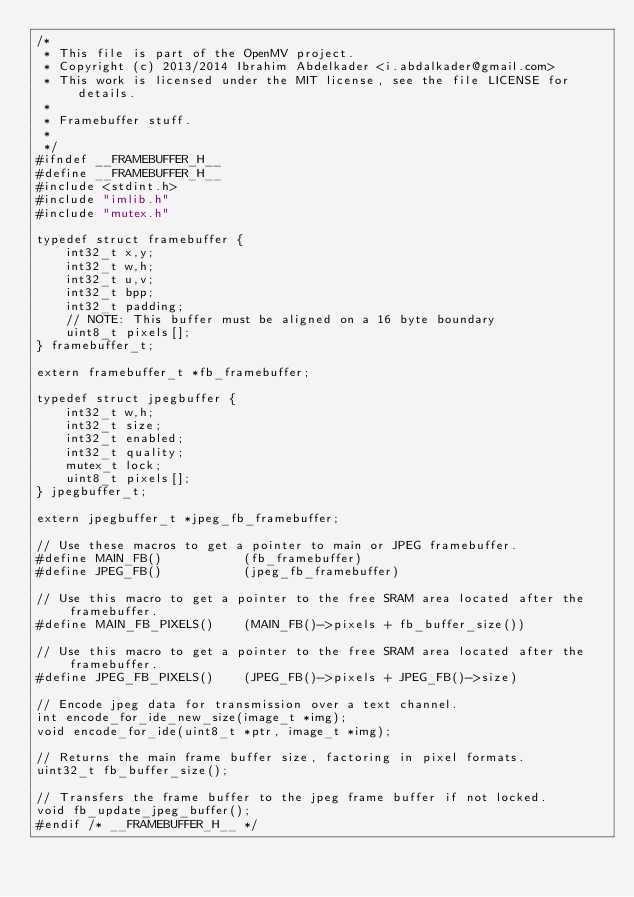Convert code to text. <code><loc_0><loc_0><loc_500><loc_500><_C_>/*
 * This file is part of the OpenMV project.
 * Copyright (c) 2013/2014 Ibrahim Abdelkader <i.abdalkader@gmail.com>
 * This work is licensed under the MIT license, see the file LICENSE for details.
 *
 * Framebuffer stuff.
 *
 */
#ifndef __FRAMEBUFFER_H__
#define __FRAMEBUFFER_H__
#include <stdint.h>
#include "imlib.h"
#include "mutex.h"

typedef struct framebuffer {
    int32_t x,y;
    int32_t w,h;
    int32_t u,v;
    int32_t bpp;
    int32_t padding;
    // NOTE: This buffer must be aligned on a 16 byte boundary
    uint8_t pixels[];
} framebuffer_t;

extern framebuffer_t *fb_framebuffer;

typedef struct jpegbuffer {
    int32_t w,h;
    int32_t size;
    int32_t enabled;
    int32_t quality;
    mutex_t lock;
    uint8_t pixels[];
} jpegbuffer_t;

extern jpegbuffer_t *jpeg_fb_framebuffer;

// Use these macros to get a pointer to main or JPEG framebuffer.
#define MAIN_FB()           (fb_framebuffer)
#define JPEG_FB()           (jpeg_fb_framebuffer)

// Use this macro to get a pointer to the free SRAM area located after the framebuffer.
#define MAIN_FB_PIXELS()    (MAIN_FB()->pixels + fb_buffer_size())

// Use this macro to get a pointer to the free SRAM area located after the framebuffer.
#define JPEG_FB_PIXELS()    (JPEG_FB()->pixels + JPEG_FB()->size)

// Encode jpeg data for transmission over a text channel.
int encode_for_ide_new_size(image_t *img);
void encode_for_ide(uint8_t *ptr, image_t *img);

// Returns the main frame buffer size, factoring in pixel formats.
uint32_t fb_buffer_size();

// Transfers the frame buffer to the jpeg frame buffer if not locked.
void fb_update_jpeg_buffer();
#endif /* __FRAMEBUFFER_H__ */
</code> 